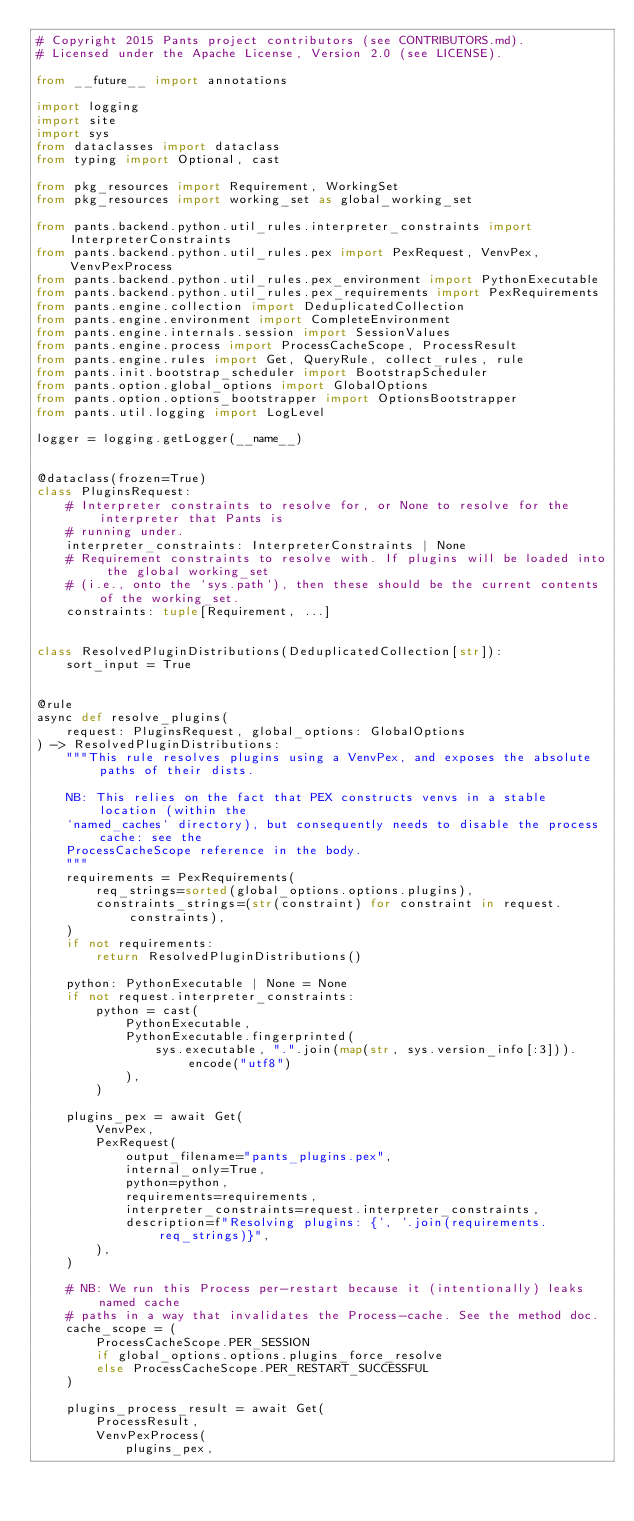<code> <loc_0><loc_0><loc_500><loc_500><_Python_># Copyright 2015 Pants project contributors (see CONTRIBUTORS.md).
# Licensed under the Apache License, Version 2.0 (see LICENSE).

from __future__ import annotations

import logging
import site
import sys
from dataclasses import dataclass
from typing import Optional, cast

from pkg_resources import Requirement, WorkingSet
from pkg_resources import working_set as global_working_set

from pants.backend.python.util_rules.interpreter_constraints import InterpreterConstraints
from pants.backend.python.util_rules.pex import PexRequest, VenvPex, VenvPexProcess
from pants.backend.python.util_rules.pex_environment import PythonExecutable
from pants.backend.python.util_rules.pex_requirements import PexRequirements
from pants.engine.collection import DeduplicatedCollection
from pants.engine.environment import CompleteEnvironment
from pants.engine.internals.session import SessionValues
from pants.engine.process import ProcessCacheScope, ProcessResult
from pants.engine.rules import Get, QueryRule, collect_rules, rule
from pants.init.bootstrap_scheduler import BootstrapScheduler
from pants.option.global_options import GlobalOptions
from pants.option.options_bootstrapper import OptionsBootstrapper
from pants.util.logging import LogLevel

logger = logging.getLogger(__name__)


@dataclass(frozen=True)
class PluginsRequest:
    # Interpreter constraints to resolve for, or None to resolve for the interpreter that Pants is
    # running under.
    interpreter_constraints: InterpreterConstraints | None
    # Requirement constraints to resolve with. If plugins will be loaded into the global working_set
    # (i.e., onto the `sys.path`), then these should be the current contents of the working_set.
    constraints: tuple[Requirement, ...]


class ResolvedPluginDistributions(DeduplicatedCollection[str]):
    sort_input = True


@rule
async def resolve_plugins(
    request: PluginsRequest, global_options: GlobalOptions
) -> ResolvedPluginDistributions:
    """This rule resolves plugins using a VenvPex, and exposes the absolute paths of their dists.

    NB: This relies on the fact that PEX constructs venvs in a stable location (within the
    `named_caches` directory), but consequently needs to disable the process cache: see the
    ProcessCacheScope reference in the body.
    """
    requirements = PexRequirements(
        req_strings=sorted(global_options.options.plugins),
        constraints_strings=(str(constraint) for constraint in request.constraints),
    )
    if not requirements:
        return ResolvedPluginDistributions()

    python: PythonExecutable | None = None
    if not request.interpreter_constraints:
        python = cast(
            PythonExecutable,
            PythonExecutable.fingerprinted(
                sys.executable, ".".join(map(str, sys.version_info[:3])).encode("utf8")
            ),
        )

    plugins_pex = await Get(
        VenvPex,
        PexRequest(
            output_filename="pants_plugins.pex",
            internal_only=True,
            python=python,
            requirements=requirements,
            interpreter_constraints=request.interpreter_constraints,
            description=f"Resolving plugins: {', '.join(requirements.req_strings)}",
        ),
    )

    # NB: We run this Process per-restart because it (intentionally) leaks named cache
    # paths in a way that invalidates the Process-cache. See the method doc.
    cache_scope = (
        ProcessCacheScope.PER_SESSION
        if global_options.options.plugins_force_resolve
        else ProcessCacheScope.PER_RESTART_SUCCESSFUL
    )

    plugins_process_result = await Get(
        ProcessResult,
        VenvPexProcess(
            plugins_pex,</code> 